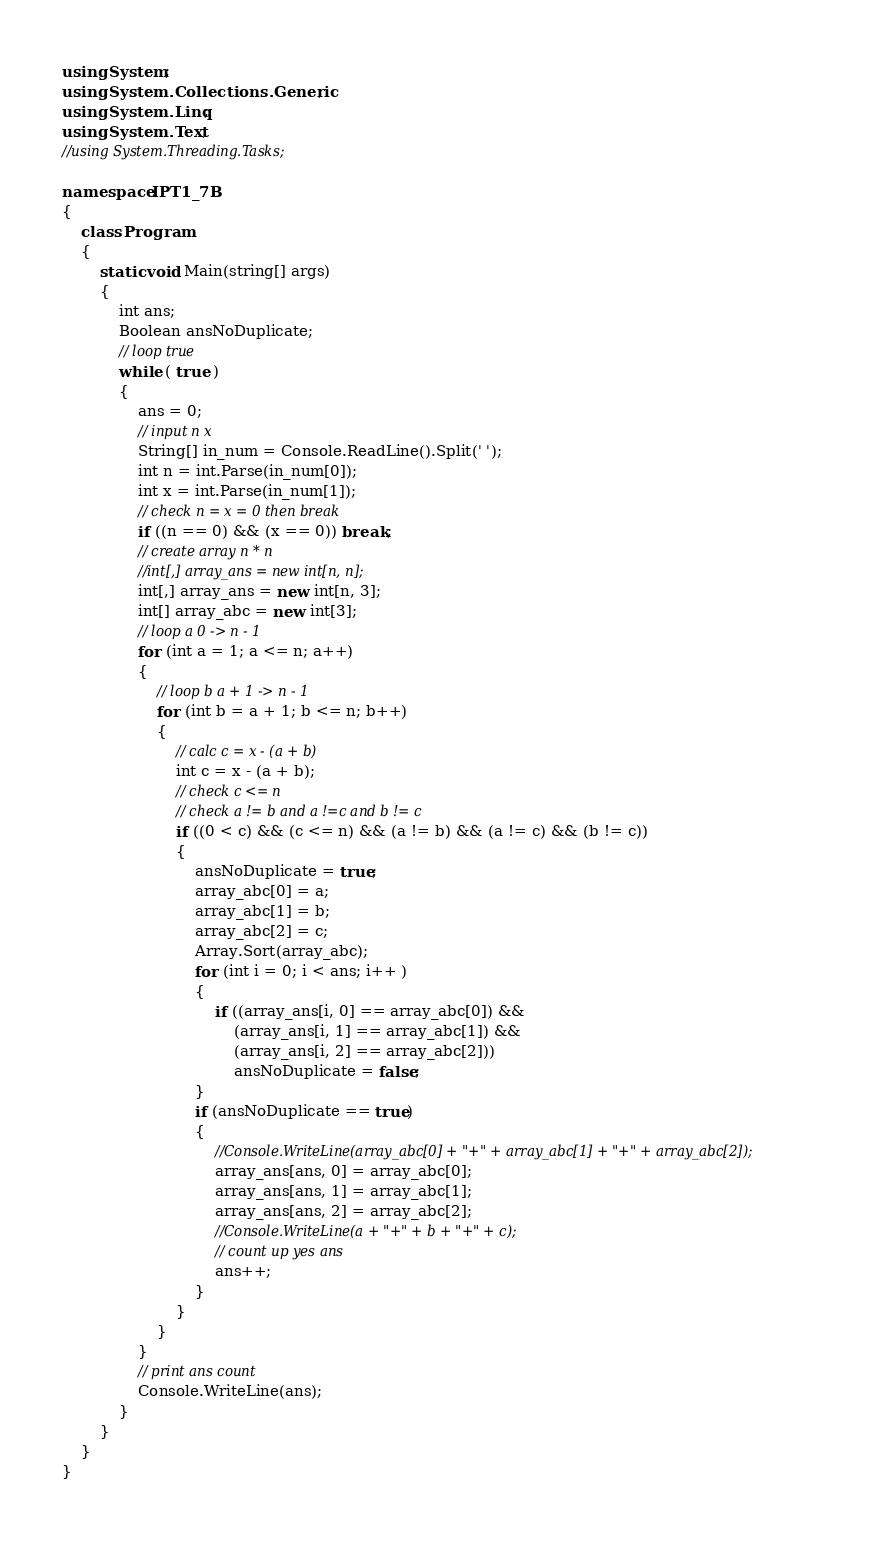<code> <loc_0><loc_0><loc_500><loc_500><_C#_>using System;
using System.Collections.Generic;
using System.Linq;
using System.Text;
//using System.Threading.Tasks;

namespace IPT1_7B
{
    class Program
    {
        static void Main(string[] args)
        {
            int ans;
            Boolean ansNoDuplicate;
            // loop true
            while ( true )
            {
                ans = 0;
                // input n x
                String[] in_num = Console.ReadLine().Split(' ');
                int n = int.Parse(in_num[0]);
                int x = int.Parse(in_num[1]);
                // check n = x = 0 then break
                if ((n == 0) && (x == 0)) break;
                // create array n * n 
                //int[,] array_ans = new int[n, n];
                int[,] array_ans = new int[n, 3];
                int[] array_abc = new int[3];
                // loop a 0 -> n - 1
                for (int a = 1; a <= n; a++)
                {
                    // loop b a + 1 -> n - 1
                    for (int b = a + 1; b <= n; b++)
                    {
                        // calc c = x - (a + b)
                        int c = x - (a + b);
                        // check c <= n
                        // check a != b and a !=c and b != c 
                        if ((0 < c) && (c <= n) && (a != b) && (a != c) && (b != c))
                        {
                            ansNoDuplicate = true;
                            array_abc[0] = a;
                            array_abc[1] = b;
                            array_abc[2] = c;
                            Array.Sort(array_abc);
                            for (int i = 0; i < ans; i++ )
                            {
                                if ((array_ans[i, 0] == array_abc[0]) &&
                                    (array_ans[i, 1] == array_abc[1]) &&
                                    (array_ans[i, 2] == array_abc[2]))
                                    ansNoDuplicate = false;
                            }
                            if (ansNoDuplicate == true)
                            {
                                //Console.WriteLine(array_abc[0] + "+" + array_abc[1] + "+" + array_abc[2]);
                                array_ans[ans, 0] = array_abc[0];
                                array_ans[ans, 1] = array_abc[1];
                                array_ans[ans, 2] = array_abc[2];
                                //Console.WriteLine(a + "+" + b + "+" + c);
                                // count up yes ans
                                ans++;
                            }
                        }
                    }
                }
                // print ans count
                Console.WriteLine(ans);
            }
        }
    }
}</code> 